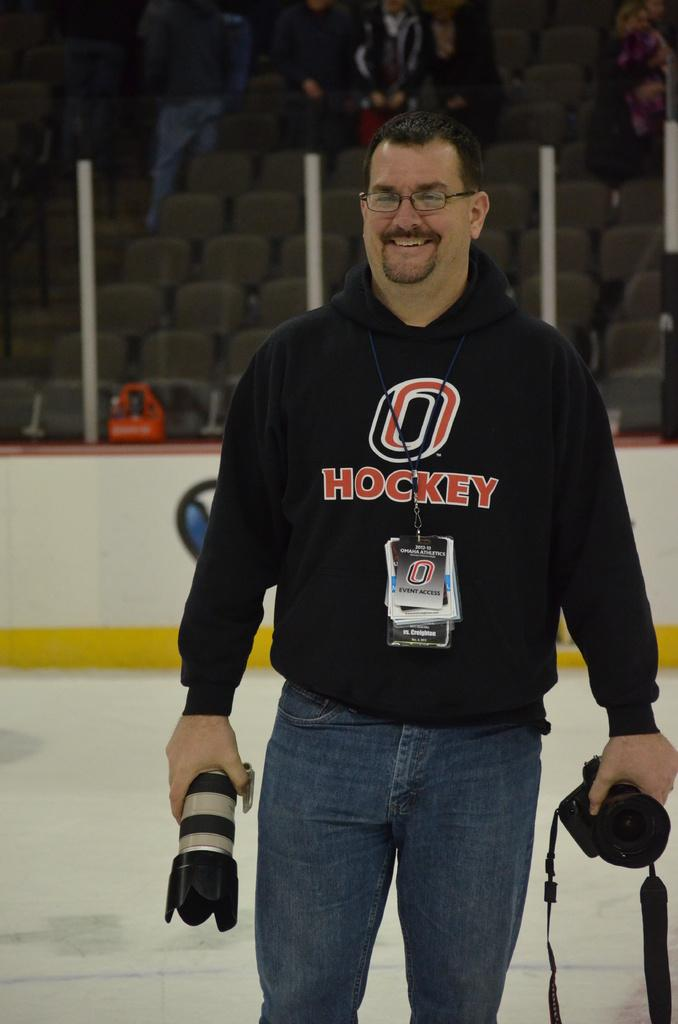What is the main subject of the image? There is a person in the image. What is the person wearing? The person is wearing a black t-shirt and jeans. What is the person holding in both hands? The person is holding a camera in both hands. What can be seen behind the person? There are chairs behind the person. What is the status of the chairs? People are sitting on the chairs. What type of plastic is covering the person's foot in the image? There is no plastic covering the person's foot in the image. What is the person doing to themselves in the image? The person is not doing anything to themselves in the image; they are holding a camera. 